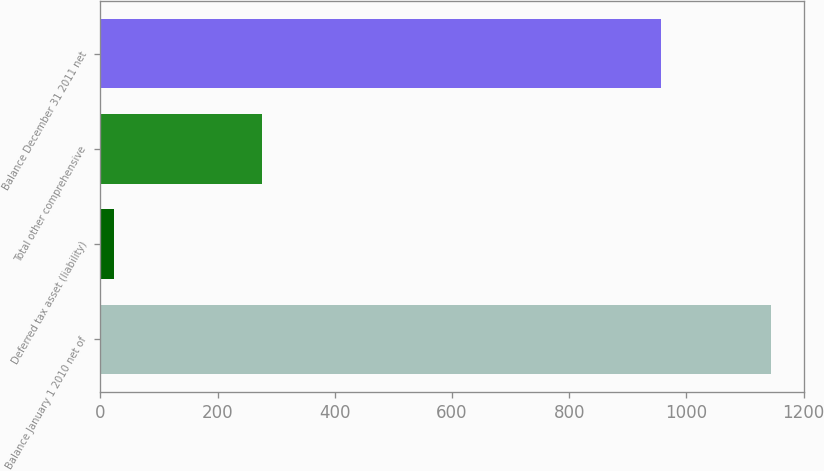Convert chart to OTSL. <chart><loc_0><loc_0><loc_500><loc_500><bar_chart><fcel>Balance January 1 2010 net of<fcel>Deferred tax asset (liability)<fcel>Total other comprehensive<fcel>Balance December 31 2011 net<nl><fcel>1144<fcel>24<fcel>275<fcel>957<nl></chart> 